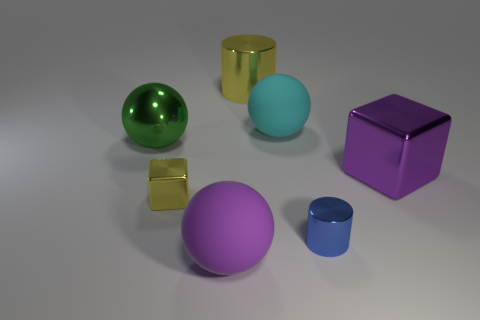Are there any patterns or repetitions visible in the image? There are no explicit patterns or repetitions in the arrangement of the objects. Each object stands as an individual entity, contributing to the diversity rather than uniformity of the scene. 